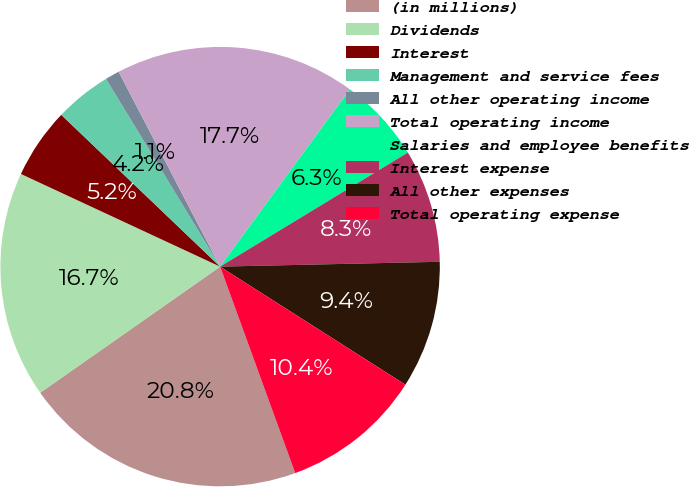<chart> <loc_0><loc_0><loc_500><loc_500><pie_chart><fcel>(in millions)<fcel>Dividends<fcel>Interest<fcel>Management and service fees<fcel>All other operating income<fcel>Total operating income<fcel>Salaries and employee benefits<fcel>Interest expense<fcel>All other expenses<fcel>Total operating expense<nl><fcel>20.82%<fcel>16.66%<fcel>5.21%<fcel>4.17%<fcel>1.05%<fcel>17.7%<fcel>6.25%<fcel>8.34%<fcel>9.38%<fcel>10.42%<nl></chart> 